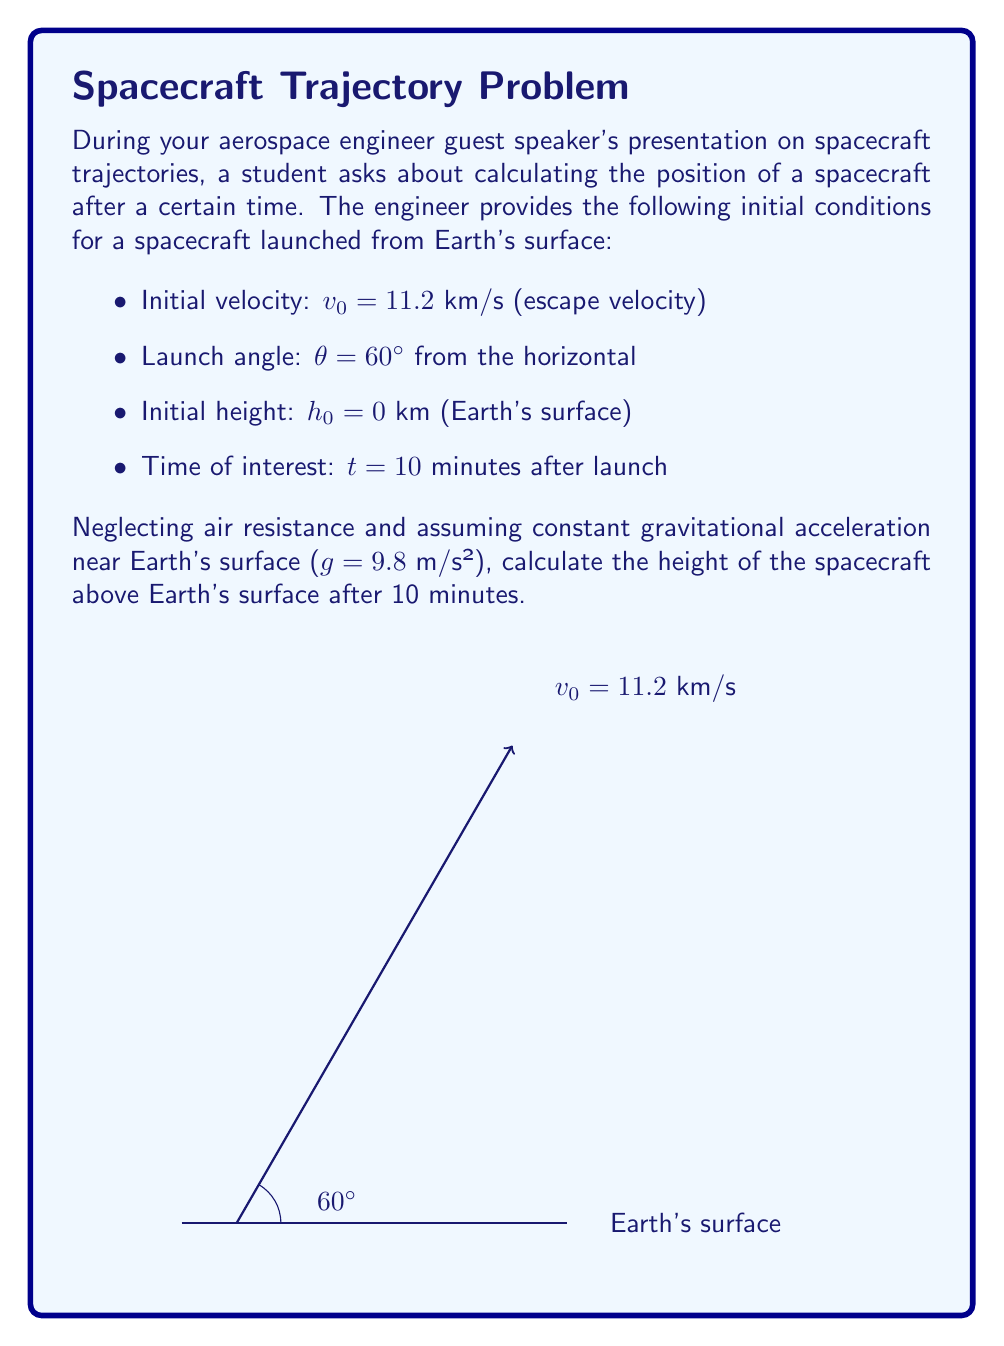Help me with this question. Let's approach this step-by-step:

1) We'll use the kinematic equation for displacement in the vertical direction:
   $$y = y_0 + v_0y t + \frac{1}{2}g t^2$$

2) First, we need to find the vertical component of the initial velocity:
   $$v_0y = v_0 \sin(\theta) = 11.2 \text{ km/s} \cdot \sin(60°) = 9.7 \text{ km/s}$$

3) Convert time to seconds:
   $$t = 10 \text{ minutes} = 600 \text{ seconds}$$

4) Now, let's substitute into our equation:
   $$y = 0 + (9.7 \text{ km/s})(600 \text{ s}) + \frac{1}{2}(-0.0098 \text{ km/s}^2)(600 \text{ s})^2$$

5) Simplify:
   $$y = 5820 \text{ km} - 1764 \text{ km} = 4056 \text{ km}$$

6) Therefore, the height of the spacecraft above Earth's surface after 10 minutes is approximately 4056 km.
Answer: 4056 km 